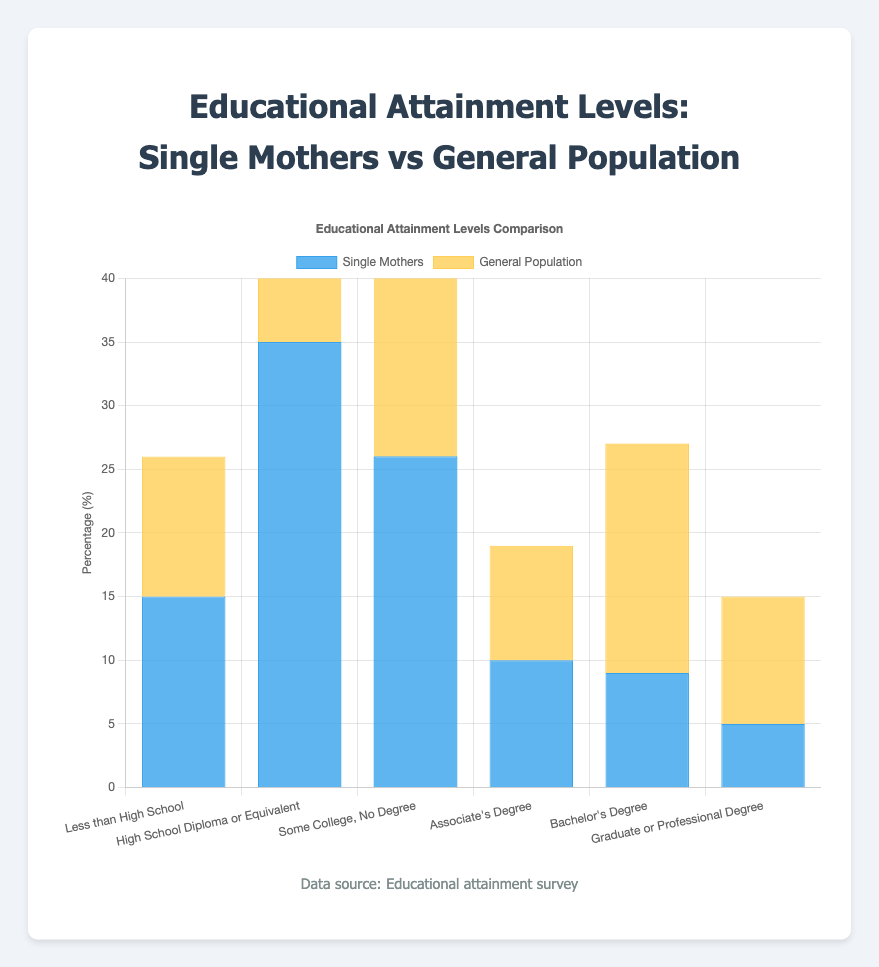What is the percentage of single mothers who have less than a high school education? The bar chart shows the percentage of single mothers with less than a high school education as 15%.
Answer: 15% Which group has a higher percentage of individuals with a Bachelor's degree? The bar chart compares single mothers and the general population; the general population has a higher percentage of individuals with a Bachelor's degree (18%) compared to single mothers (9%).
Answer: General Population How many percentage points higher is the percentage of single mothers with some college, no degree compared to the general population? The percentage of single mothers with some college, no degree is 26%, while the general population is 22%. The difference is 26% - 22% = 4 percentage points.
Answer: 4 percentage points Is the percentage of single mothers with an Associate's degree higher or lower than the general population? The bar chart indicates that the percentage of single mothers with an Associate's degree is 10%, while the general population is 9%. Thus, it is higher for single mothers.
Answer: Higher What is the sum of the percentages for single mothers who have a Bachelor's degree and those who have a graduate or professional degree? According to the bar chart, the percentage of single mothers with a Bachelor's degree is 9%, and with a graduate or professional degree is 5%. The sum is 9% + 5% = 14%.
Answer: 14% What is the difference in percentage between single mothers and the general population for those with a high school diploma or equivalent? The bar chart shows that 35% of single mothers have a high school diploma or equivalent, compared to 30% of the general population. The difference is 35% - 30% = 5 percentage points.
Answer: 5 percentage points Which educational attainment level shows the greatest disparity between single mothers and the general population? Comparing all the categories in the bar chart, the greatest disparity is in the Bachelor's degree category, where the general population has 18% and single mothers have 9%, a difference of 9 percentage points.
Answer: Bachelor's Degree For which educational attainment level are the percentages for single mothers and the general population closest? The bar chart indicates that the percentages for those with an Associate's degree are closest: 10% for single mothers and 9% for the general population.
Answer: Associate's Degree 